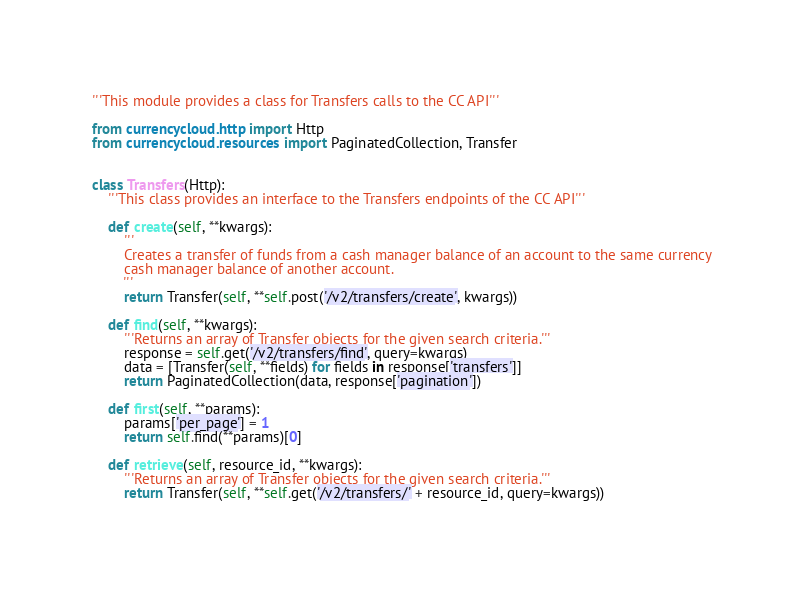Convert code to text. <code><loc_0><loc_0><loc_500><loc_500><_Python_>'''This module provides a class for Transfers calls to the CC API'''

from currencycloud.http import Http
from currencycloud.resources import PaginatedCollection, Transfer


class Transfers(Http):
    '''This class provides an interface to the Transfers endpoints of the CC API'''

    def create(self, **kwargs):
        '''
        Creates a transfer of funds from a cash manager balance of an account to the same currency
        cash manager balance of another account.
        '''
        return Transfer(self, **self.post('/v2/transfers/create', kwargs))

    def find(self, **kwargs):
        '''Returns an array of Transfer objects for the given search criteria.'''
        response = self.get('/v2/transfers/find', query=kwargs)
        data = [Transfer(self, **fields) for fields in response['transfers']]
        return PaginatedCollection(data, response['pagination'])

    def first(self, **params):
        params['per_page'] = 1
        return self.find(**params)[0]

    def retrieve(self, resource_id, **kwargs):
        '''Returns an array of Transfer objects for the given search criteria.'''
        return Transfer(self, **self.get('/v2/transfers/' + resource_id, query=kwargs))
</code> 